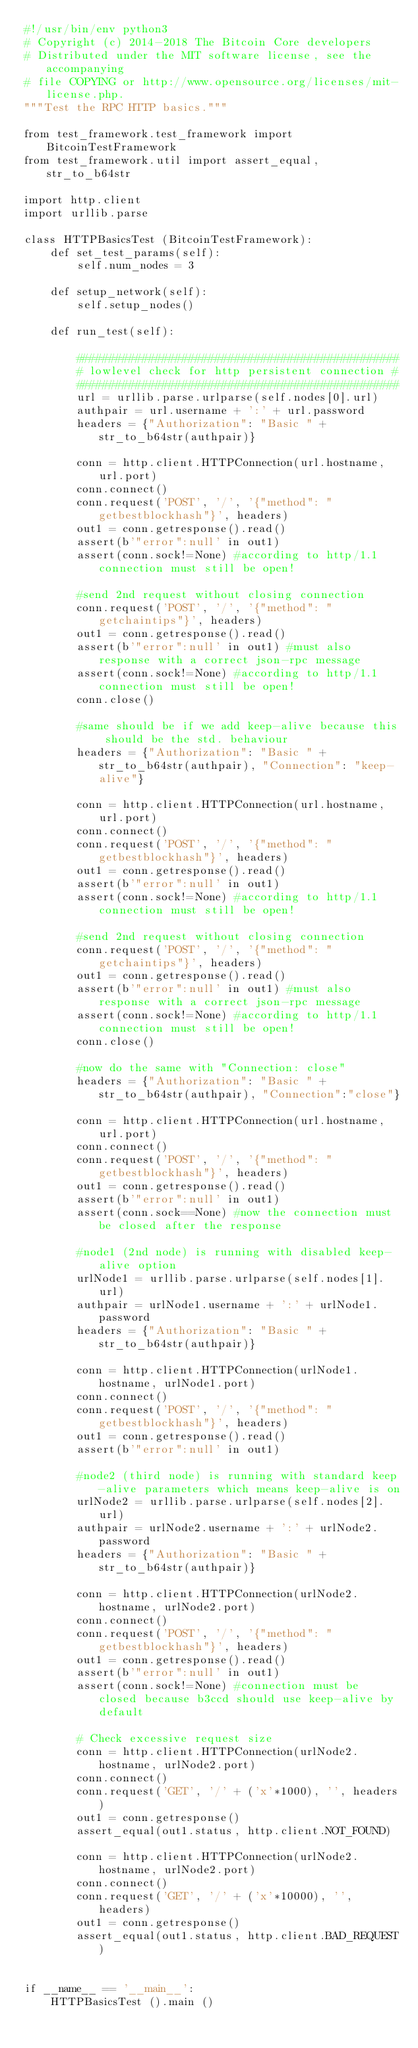Convert code to text. <code><loc_0><loc_0><loc_500><loc_500><_Python_>#!/usr/bin/env python3
# Copyright (c) 2014-2018 The Bitcoin Core developers
# Distributed under the MIT software license, see the accompanying
# file COPYING or http://www.opensource.org/licenses/mit-license.php.
"""Test the RPC HTTP basics."""

from test_framework.test_framework import BitcoinTestFramework
from test_framework.util import assert_equal, str_to_b64str

import http.client
import urllib.parse

class HTTPBasicsTest (BitcoinTestFramework):
    def set_test_params(self):
        self.num_nodes = 3

    def setup_network(self):
        self.setup_nodes()

    def run_test(self):

        #################################################
        # lowlevel check for http persistent connection #
        #################################################
        url = urllib.parse.urlparse(self.nodes[0].url)
        authpair = url.username + ':' + url.password
        headers = {"Authorization": "Basic " + str_to_b64str(authpair)}

        conn = http.client.HTTPConnection(url.hostname, url.port)
        conn.connect()
        conn.request('POST', '/', '{"method": "getbestblockhash"}', headers)
        out1 = conn.getresponse().read()
        assert(b'"error":null' in out1)
        assert(conn.sock!=None) #according to http/1.1 connection must still be open!

        #send 2nd request without closing connection
        conn.request('POST', '/', '{"method": "getchaintips"}', headers)
        out1 = conn.getresponse().read()
        assert(b'"error":null' in out1) #must also response with a correct json-rpc message
        assert(conn.sock!=None) #according to http/1.1 connection must still be open!
        conn.close()

        #same should be if we add keep-alive because this should be the std. behaviour
        headers = {"Authorization": "Basic " + str_to_b64str(authpair), "Connection": "keep-alive"}

        conn = http.client.HTTPConnection(url.hostname, url.port)
        conn.connect()
        conn.request('POST', '/', '{"method": "getbestblockhash"}', headers)
        out1 = conn.getresponse().read()
        assert(b'"error":null' in out1)
        assert(conn.sock!=None) #according to http/1.1 connection must still be open!

        #send 2nd request without closing connection
        conn.request('POST', '/', '{"method": "getchaintips"}', headers)
        out1 = conn.getresponse().read()
        assert(b'"error":null' in out1) #must also response with a correct json-rpc message
        assert(conn.sock!=None) #according to http/1.1 connection must still be open!
        conn.close()

        #now do the same with "Connection: close"
        headers = {"Authorization": "Basic " + str_to_b64str(authpair), "Connection":"close"}

        conn = http.client.HTTPConnection(url.hostname, url.port)
        conn.connect()
        conn.request('POST', '/', '{"method": "getbestblockhash"}', headers)
        out1 = conn.getresponse().read()
        assert(b'"error":null' in out1)
        assert(conn.sock==None) #now the connection must be closed after the response

        #node1 (2nd node) is running with disabled keep-alive option
        urlNode1 = urllib.parse.urlparse(self.nodes[1].url)
        authpair = urlNode1.username + ':' + urlNode1.password
        headers = {"Authorization": "Basic " + str_to_b64str(authpair)}

        conn = http.client.HTTPConnection(urlNode1.hostname, urlNode1.port)
        conn.connect()
        conn.request('POST', '/', '{"method": "getbestblockhash"}', headers)
        out1 = conn.getresponse().read()
        assert(b'"error":null' in out1)

        #node2 (third node) is running with standard keep-alive parameters which means keep-alive is on
        urlNode2 = urllib.parse.urlparse(self.nodes[2].url)
        authpair = urlNode2.username + ':' + urlNode2.password
        headers = {"Authorization": "Basic " + str_to_b64str(authpair)}

        conn = http.client.HTTPConnection(urlNode2.hostname, urlNode2.port)
        conn.connect()
        conn.request('POST', '/', '{"method": "getbestblockhash"}', headers)
        out1 = conn.getresponse().read()
        assert(b'"error":null' in out1)
        assert(conn.sock!=None) #connection must be closed because b3ccd should use keep-alive by default

        # Check excessive request size
        conn = http.client.HTTPConnection(urlNode2.hostname, urlNode2.port)
        conn.connect()
        conn.request('GET', '/' + ('x'*1000), '', headers)
        out1 = conn.getresponse()
        assert_equal(out1.status, http.client.NOT_FOUND)

        conn = http.client.HTTPConnection(urlNode2.hostname, urlNode2.port)
        conn.connect()
        conn.request('GET', '/' + ('x'*10000), '', headers)
        out1 = conn.getresponse()
        assert_equal(out1.status, http.client.BAD_REQUEST)


if __name__ == '__main__':
    HTTPBasicsTest ().main ()
</code> 